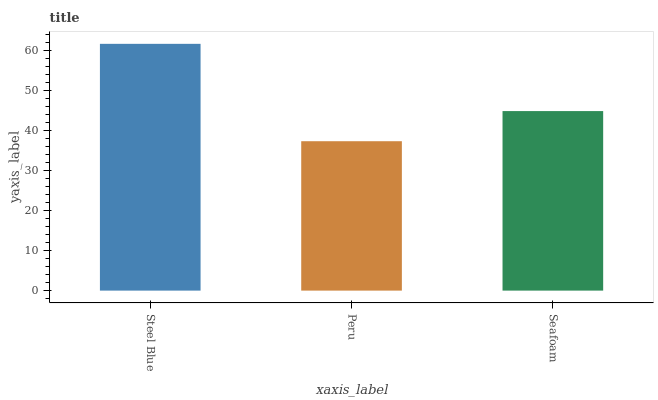Is Peru the minimum?
Answer yes or no. Yes. Is Steel Blue the maximum?
Answer yes or no. Yes. Is Seafoam the minimum?
Answer yes or no. No. Is Seafoam the maximum?
Answer yes or no. No. Is Seafoam greater than Peru?
Answer yes or no. Yes. Is Peru less than Seafoam?
Answer yes or no. Yes. Is Peru greater than Seafoam?
Answer yes or no. No. Is Seafoam less than Peru?
Answer yes or no. No. Is Seafoam the high median?
Answer yes or no. Yes. Is Seafoam the low median?
Answer yes or no. Yes. Is Peru the high median?
Answer yes or no. No. Is Peru the low median?
Answer yes or no. No. 